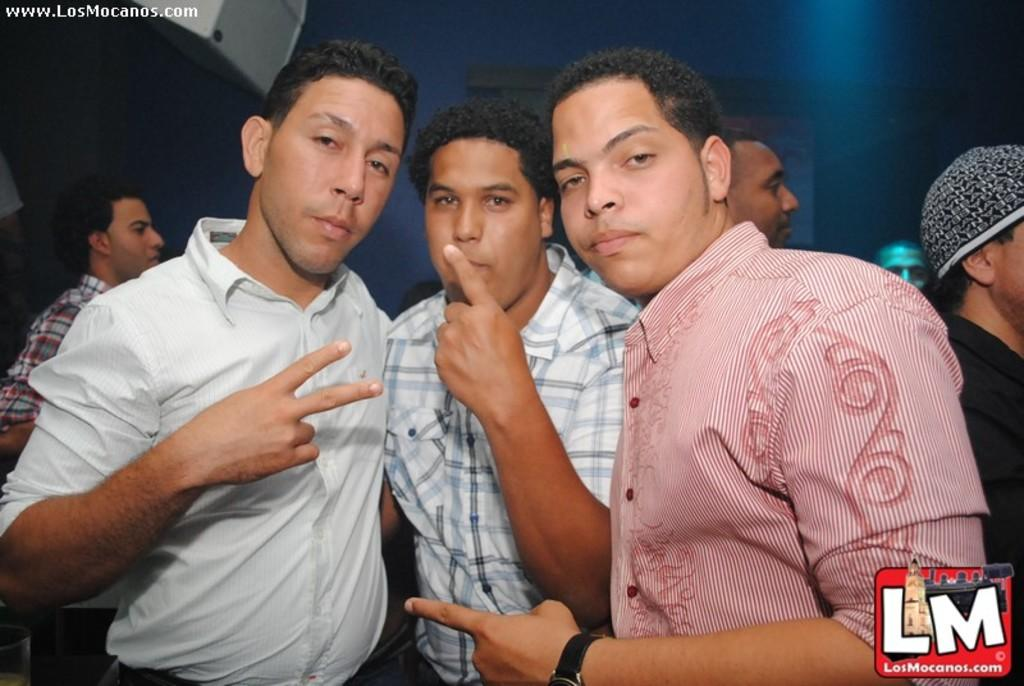How many men are standing in the image? There are three men standing in the image. Can you describe the background of the image? There are people, a wall, and a screen in the background of the image. What is located on the left side at the top of the image? There is an object on the left side at the top of the image. What type of fuel is being used by the mountain in the image? There is no mountain present in the image, and therefore no fuel can be associated with it. 